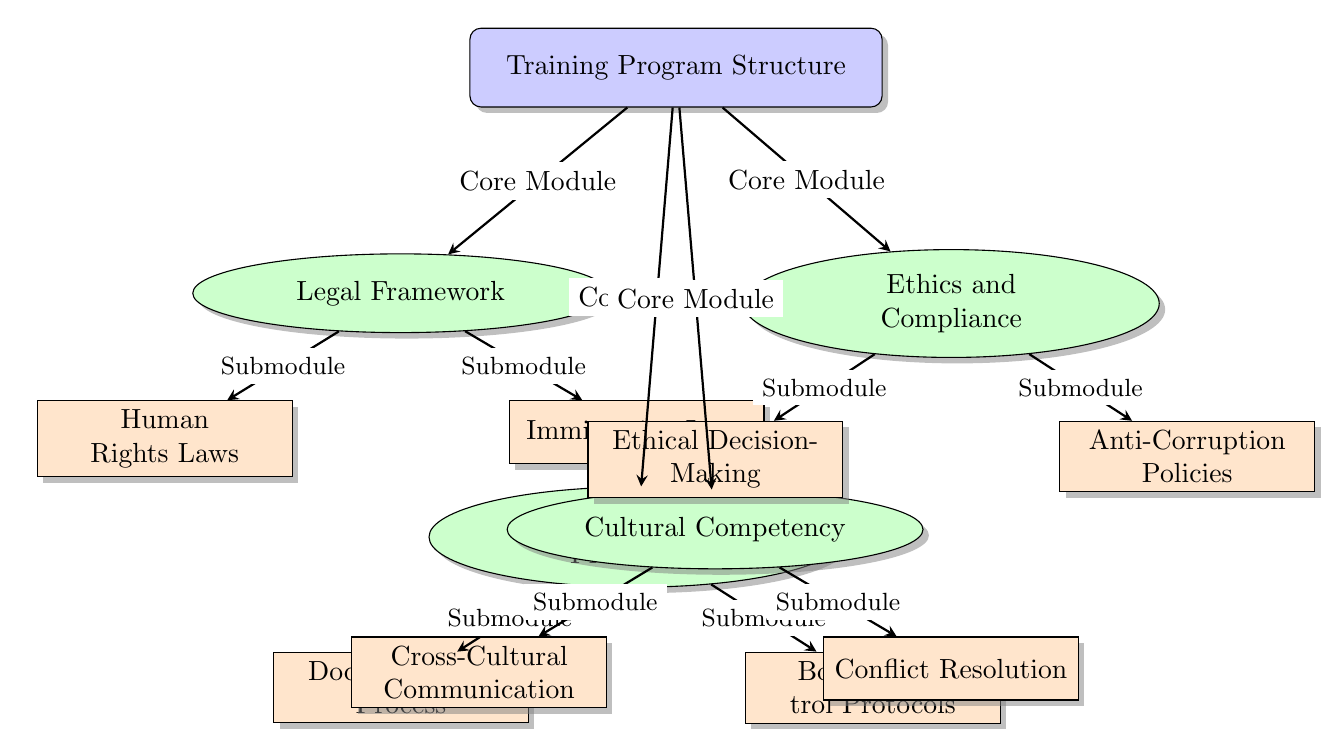What are the four core modules in the training program? The diagram lists four core modules stemming from the main node, which are Legal Framework, Operational Procedures, Cultural Competency, and Ethics and Compliance.
Answer: Legal Framework, Operational Procedures, Cultural Competency, Ethics and Compliance How many submodules are under the Legal Framework core module? Under the Legal Framework module, there are two submodules identified in the diagram: Human Rights Laws and Immigration Laws.
Answer: 2 Which core module includes Cross-Cultural Communication as a submodule? Cross-Cultural Communication appears as a submodule under the Cultural Competency core module, which is indicated by the arrow connecting them in the diagram.
Answer: Cultural Competency What is the relationship between Operational Procedures and Documentation Process? In the diagram, Documentation Process is a submodule of Operational Procedures, shown by the arrow pointing from the Operational Procedures module to the Documentation Process submodule.
Answer: Submodule How many total submodules are present across all core modules? By counting the submodules from each of the four core modules, we find Human Rights Laws and Immigration Laws (2) under Legal Framework, Documentation Process and Border Control Protocols (2) under Operational Procedures, Cross-Cultural Communication and Conflict Resolution (2) under Cultural Competency, and Ethical Decision-Making and Anti-Corruption Policies (2) under Ethics and Compliance. This gives us a total of 2 + 2 + 2 + 2 = 8 submodules.
Answer: 8 